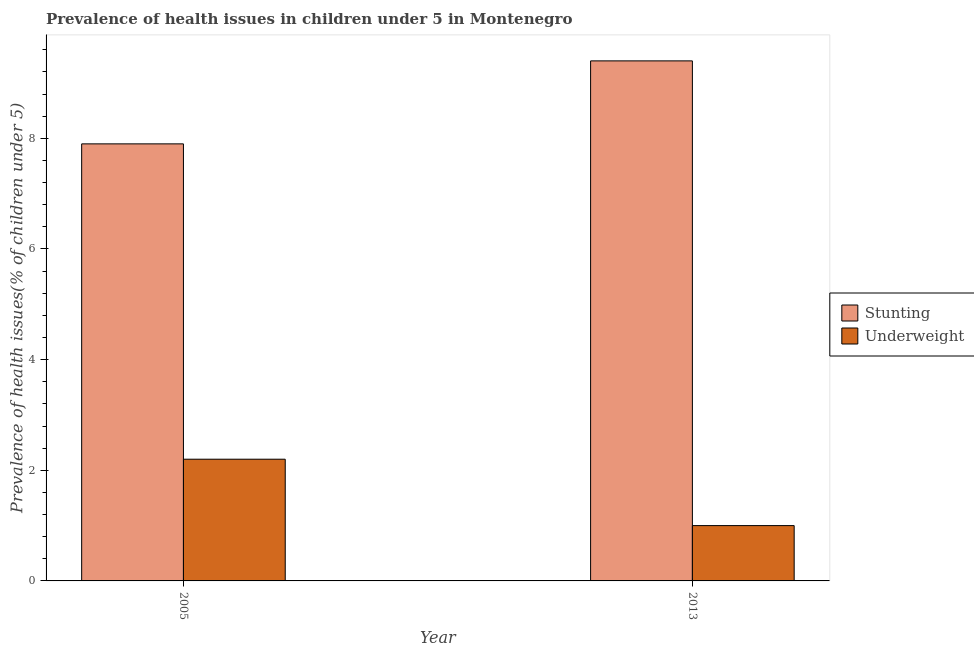How many different coloured bars are there?
Provide a succinct answer. 2. How many groups of bars are there?
Keep it short and to the point. 2. Are the number of bars per tick equal to the number of legend labels?
Keep it short and to the point. Yes. Are the number of bars on each tick of the X-axis equal?
Your response must be concise. Yes. How many bars are there on the 1st tick from the left?
Offer a very short reply. 2. What is the percentage of underweight children in 2005?
Provide a short and direct response. 2.2. Across all years, what is the maximum percentage of underweight children?
Provide a succinct answer. 2.2. Across all years, what is the minimum percentage of underweight children?
Offer a terse response. 1. What is the total percentage of stunted children in the graph?
Make the answer very short. 17.3. What is the difference between the percentage of underweight children in 2005 and that in 2013?
Give a very brief answer. 1.2. What is the difference between the percentage of stunted children in 2005 and the percentage of underweight children in 2013?
Ensure brevity in your answer.  -1.5. What is the average percentage of stunted children per year?
Your response must be concise. 8.65. In the year 2005, what is the difference between the percentage of underweight children and percentage of stunted children?
Offer a very short reply. 0. In how many years, is the percentage of underweight children greater than 5.2 %?
Provide a short and direct response. 0. What is the ratio of the percentage of stunted children in 2005 to that in 2013?
Give a very brief answer. 0.84. Is the percentage of stunted children in 2005 less than that in 2013?
Provide a succinct answer. Yes. What does the 1st bar from the left in 2013 represents?
Your answer should be compact. Stunting. What does the 2nd bar from the right in 2005 represents?
Ensure brevity in your answer.  Stunting. Does the graph contain grids?
Make the answer very short. No. How many legend labels are there?
Make the answer very short. 2. What is the title of the graph?
Your response must be concise. Prevalence of health issues in children under 5 in Montenegro. Does "Banks" appear as one of the legend labels in the graph?
Your response must be concise. No. What is the label or title of the Y-axis?
Your answer should be very brief. Prevalence of health issues(% of children under 5). What is the Prevalence of health issues(% of children under 5) of Stunting in 2005?
Make the answer very short. 7.9. What is the Prevalence of health issues(% of children under 5) in Underweight in 2005?
Offer a terse response. 2.2. What is the Prevalence of health issues(% of children under 5) in Stunting in 2013?
Your response must be concise. 9.4. What is the Prevalence of health issues(% of children under 5) in Underweight in 2013?
Offer a very short reply. 1. Across all years, what is the maximum Prevalence of health issues(% of children under 5) of Stunting?
Your answer should be very brief. 9.4. Across all years, what is the maximum Prevalence of health issues(% of children under 5) in Underweight?
Your answer should be compact. 2.2. Across all years, what is the minimum Prevalence of health issues(% of children under 5) of Stunting?
Make the answer very short. 7.9. Across all years, what is the minimum Prevalence of health issues(% of children under 5) of Underweight?
Give a very brief answer. 1. What is the difference between the Prevalence of health issues(% of children under 5) in Underweight in 2005 and that in 2013?
Your response must be concise. 1.2. What is the difference between the Prevalence of health issues(% of children under 5) of Stunting in 2005 and the Prevalence of health issues(% of children under 5) of Underweight in 2013?
Provide a succinct answer. 6.9. What is the average Prevalence of health issues(% of children under 5) in Stunting per year?
Your answer should be very brief. 8.65. What is the average Prevalence of health issues(% of children under 5) in Underweight per year?
Make the answer very short. 1.6. In the year 2005, what is the difference between the Prevalence of health issues(% of children under 5) of Stunting and Prevalence of health issues(% of children under 5) of Underweight?
Offer a terse response. 5.7. In the year 2013, what is the difference between the Prevalence of health issues(% of children under 5) of Stunting and Prevalence of health issues(% of children under 5) of Underweight?
Ensure brevity in your answer.  8.4. What is the ratio of the Prevalence of health issues(% of children under 5) of Stunting in 2005 to that in 2013?
Keep it short and to the point. 0.84. What is the difference between the highest and the second highest Prevalence of health issues(% of children under 5) of Stunting?
Offer a terse response. 1.5. What is the difference between the highest and the second highest Prevalence of health issues(% of children under 5) in Underweight?
Make the answer very short. 1.2. What is the difference between the highest and the lowest Prevalence of health issues(% of children under 5) of Stunting?
Offer a terse response. 1.5. What is the difference between the highest and the lowest Prevalence of health issues(% of children under 5) in Underweight?
Keep it short and to the point. 1.2. 